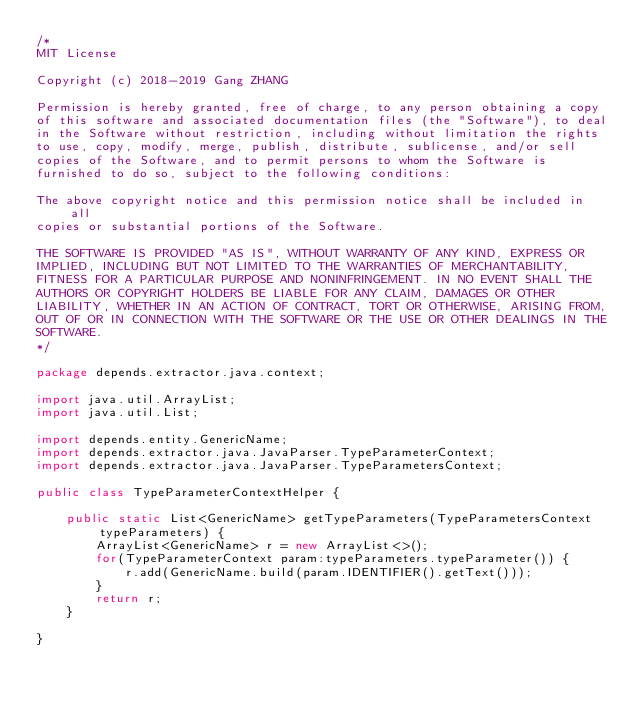<code> <loc_0><loc_0><loc_500><loc_500><_Java_>/*
MIT License

Copyright (c) 2018-2019 Gang ZHANG

Permission is hereby granted, free of charge, to any person obtaining a copy
of this software and associated documentation files (the "Software"), to deal
in the Software without restriction, including without limitation the rights
to use, copy, modify, merge, publish, distribute, sublicense, and/or sell
copies of the Software, and to permit persons to whom the Software is
furnished to do so, subject to the following conditions:

The above copyright notice and this permission notice shall be included in all
copies or substantial portions of the Software.

THE SOFTWARE IS PROVIDED "AS IS", WITHOUT WARRANTY OF ANY KIND, EXPRESS OR
IMPLIED, INCLUDING BUT NOT LIMITED TO THE WARRANTIES OF MERCHANTABILITY,
FITNESS FOR A PARTICULAR PURPOSE AND NONINFRINGEMENT. IN NO EVENT SHALL THE
AUTHORS OR COPYRIGHT HOLDERS BE LIABLE FOR ANY CLAIM, DAMAGES OR OTHER
LIABILITY, WHETHER IN AN ACTION OF CONTRACT, TORT OR OTHERWISE, ARISING FROM,
OUT OF OR IN CONNECTION WITH THE SOFTWARE OR THE USE OR OTHER DEALINGS IN THE
SOFTWARE.
*/

package depends.extractor.java.context;

import java.util.ArrayList;
import java.util.List;

import depends.entity.GenericName;
import depends.extractor.java.JavaParser.TypeParameterContext;
import depends.extractor.java.JavaParser.TypeParametersContext;

public class TypeParameterContextHelper {

	public static List<GenericName> getTypeParameters(TypeParametersContext typeParameters) {
		ArrayList<GenericName> r = new ArrayList<>();
		for(TypeParameterContext param:typeParameters.typeParameter()) {
			r.add(GenericName.build(param.IDENTIFIER().getText()));
		}
		return r;
	}

}
</code> 